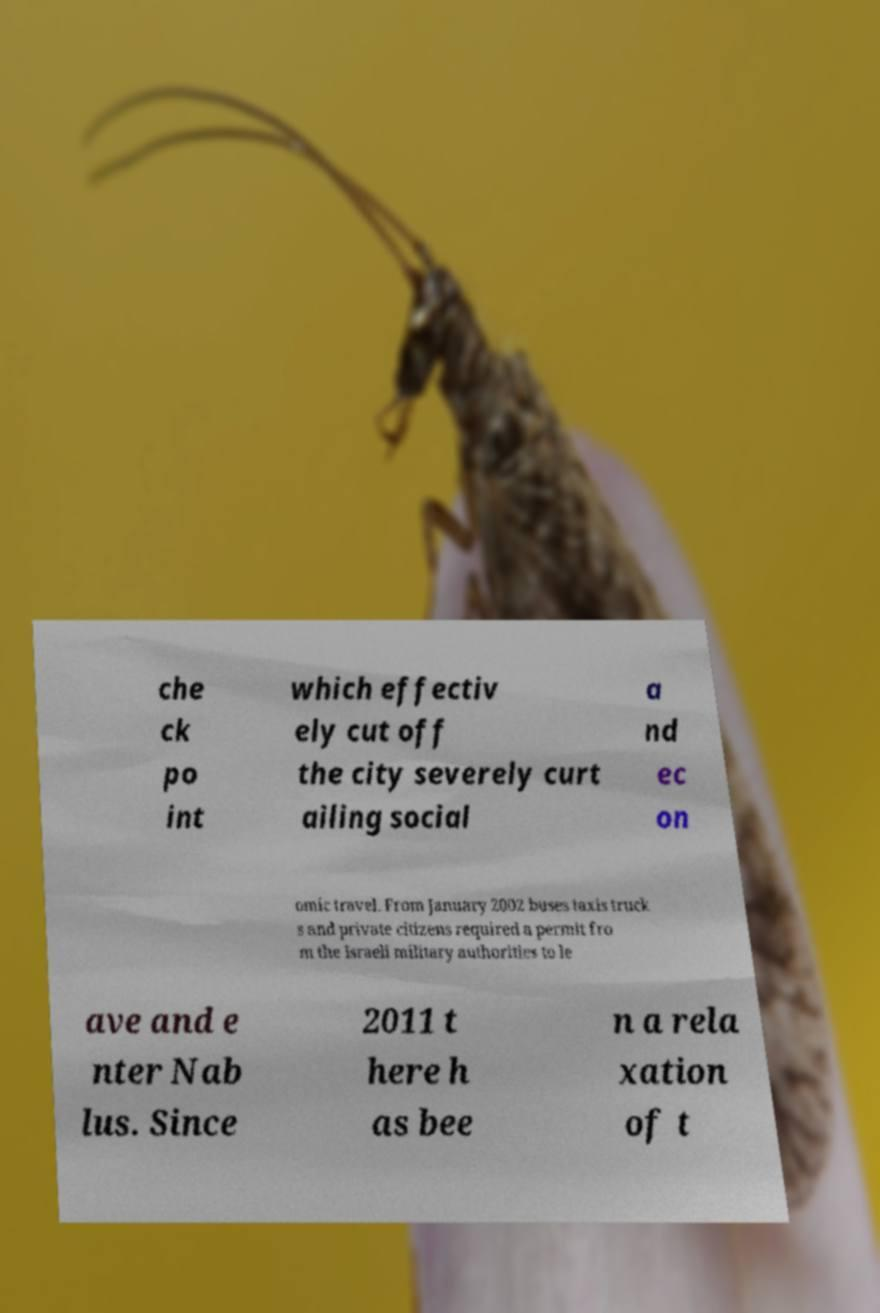There's text embedded in this image that I need extracted. Can you transcribe it verbatim? che ck po int which effectiv ely cut off the city severely curt ailing social a nd ec on omic travel. From January 2002 buses taxis truck s and private citizens required a permit fro m the Israeli military authorities to le ave and e nter Nab lus. Since 2011 t here h as bee n a rela xation of t 